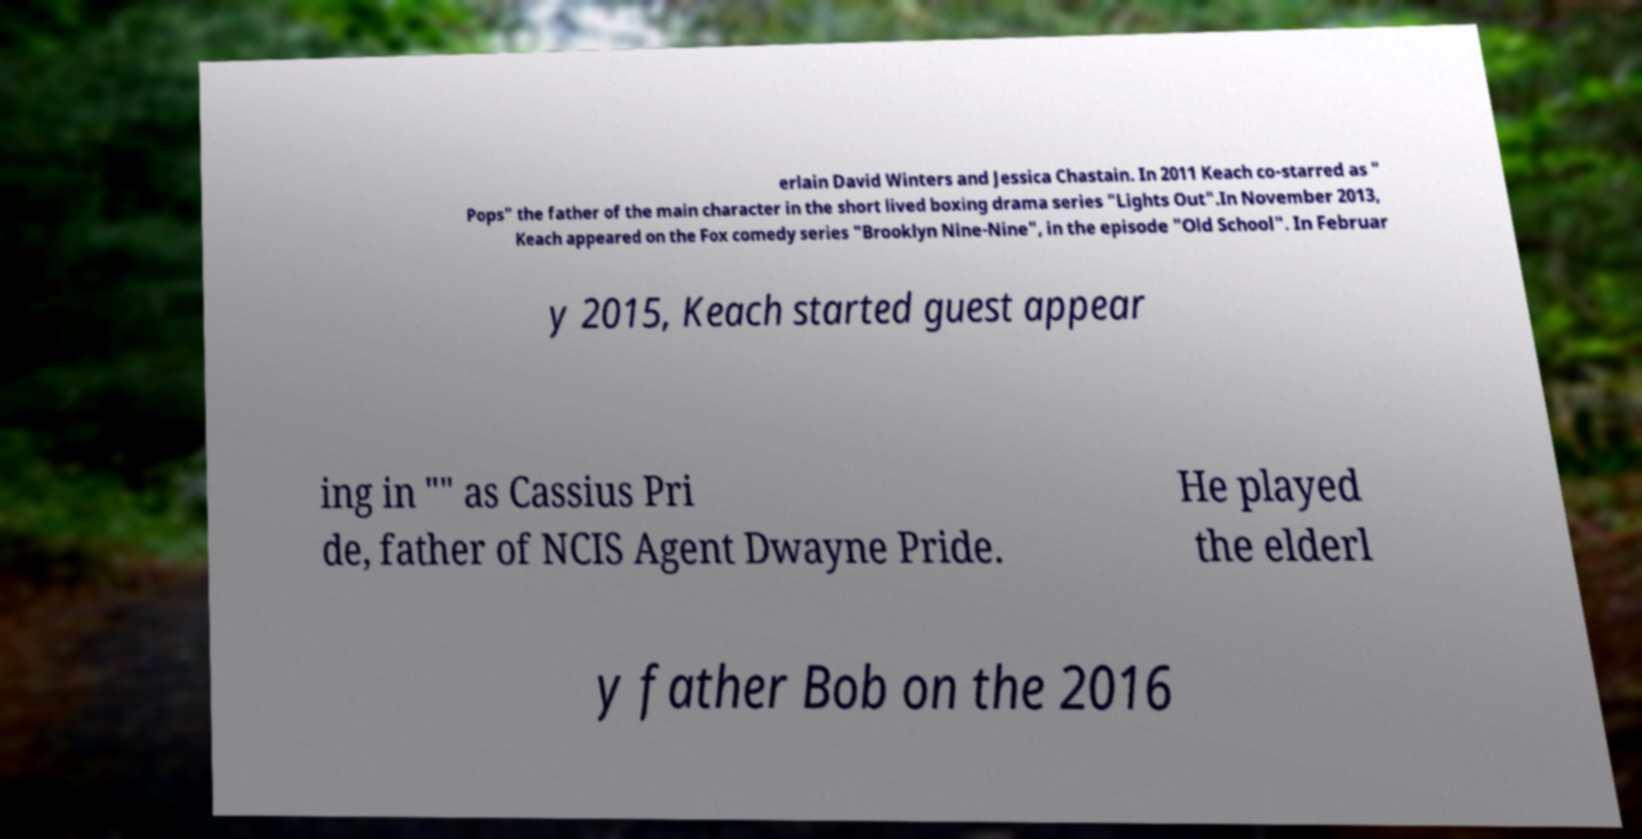What messages or text are displayed in this image? I need them in a readable, typed format. erlain David Winters and Jessica Chastain. In 2011 Keach co-starred as " Pops" the father of the main character in the short lived boxing drama series "Lights Out".In November 2013, Keach appeared on the Fox comedy series "Brooklyn Nine-Nine", in the episode "Old School". In Februar y 2015, Keach started guest appear ing in "" as Cassius Pri de, father of NCIS Agent Dwayne Pride. He played the elderl y father Bob on the 2016 